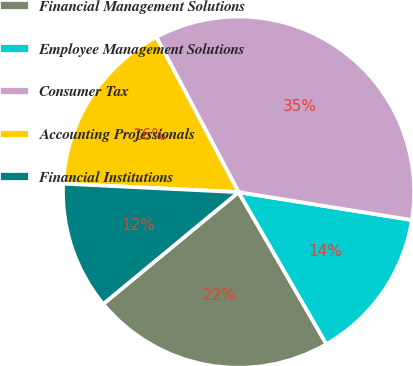Convert chart. <chart><loc_0><loc_0><loc_500><loc_500><pie_chart><fcel>Financial Management Solutions<fcel>Employee Management Solutions<fcel>Consumer Tax<fcel>Accounting Professionals<fcel>Financial Institutions<nl><fcel>22.35%<fcel>14.12%<fcel>35.29%<fcel>16.47%<fcel>11.76%<nl></chart> 